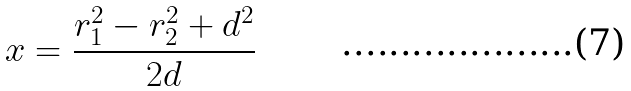<formula> <loc_0><loc_0><loc_500><loc_500>x = \frac { r _ { 1 } ^ { 2 } - r _ { 2 } ^ { 2 } + d ^ { 2 } } { 2 d }</formula> 